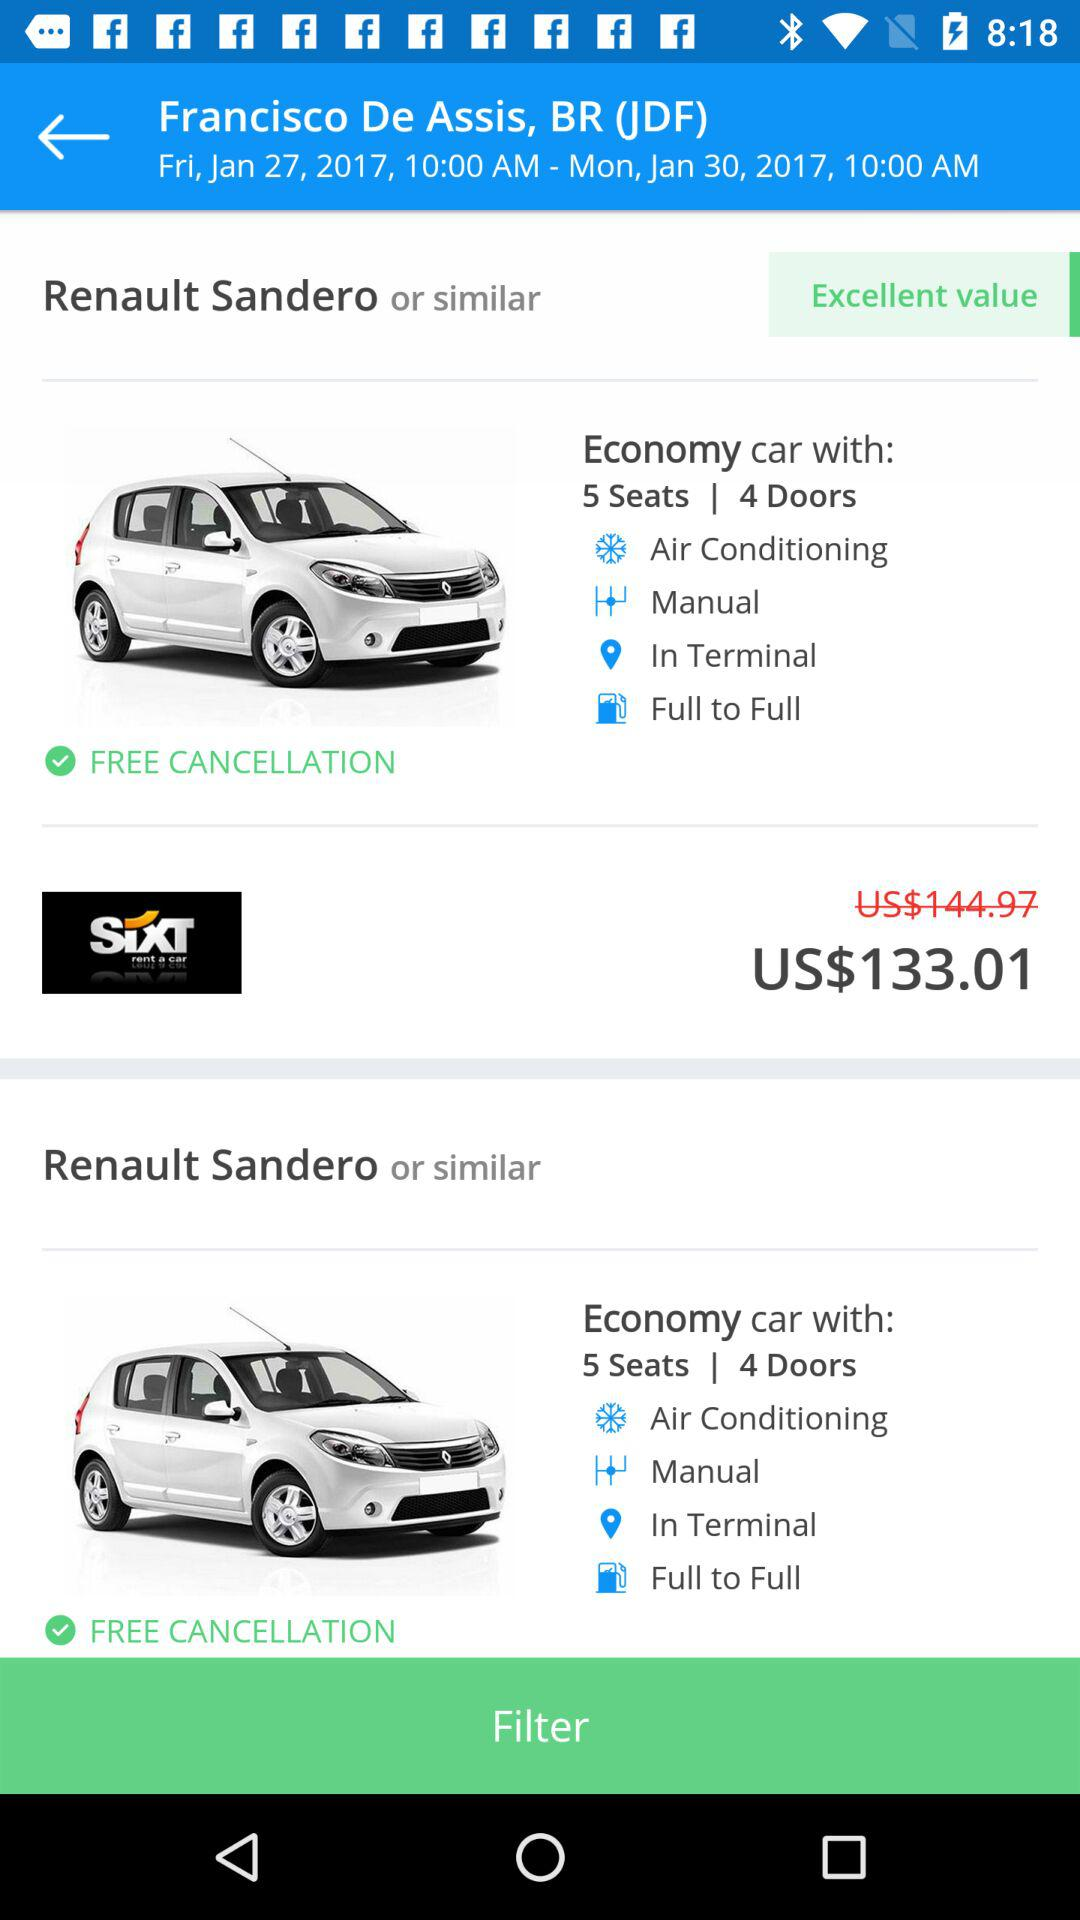What is the car name? The car name is "Renault Sandero". 